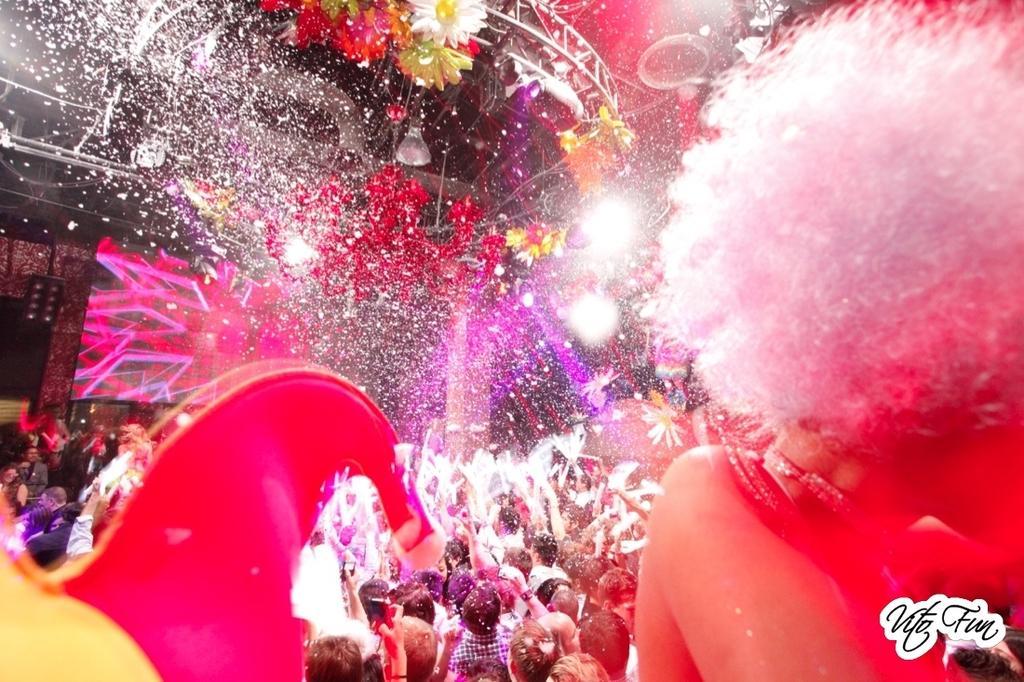Please provide a concise description of this image. On the bottom right, there is a watermark. On the right side, there is a person with white hair. On the left side, there is an object. In the background, there are persons, there are lights and flowers attached to a roof and there are other objects. 